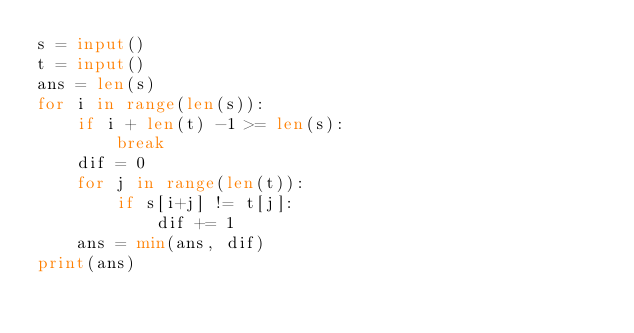<code> <loc_0><loc_0><loc_500><loc_500><_Python_>s = input()
t = input()
ans = len(s)
for i in range(len(s)):
    if i + len(t) -1 >= len(s):
        break
    dif = 0
    for j in range(len(t)):
        if s[i+j] != t[j]:
            dif += 1
    ans = min(ans, dif)
print(ans)
        
</code> 